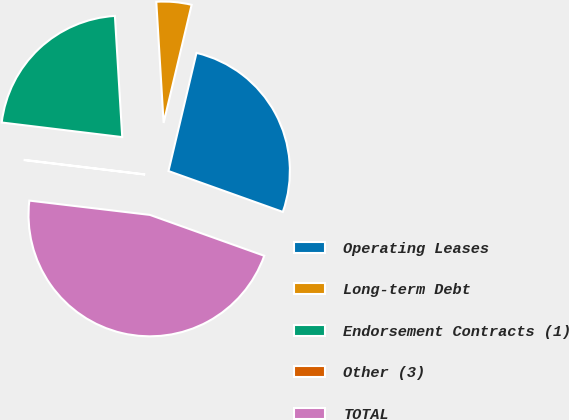Convert chart. <chart><loc_0><loc_0><loc_500><loc_500><pie_chart><fcel>Operating Leases<fcel>Long-term Debt<fcel>Endorsement Contracts (1)<fcel>Other (3)<fcel>TOTAL<nl><fcel>26.76%<fcel>4.67%<fcel>22.12%<fcel>0.04%<fcel>46.42%<nl></chart> 